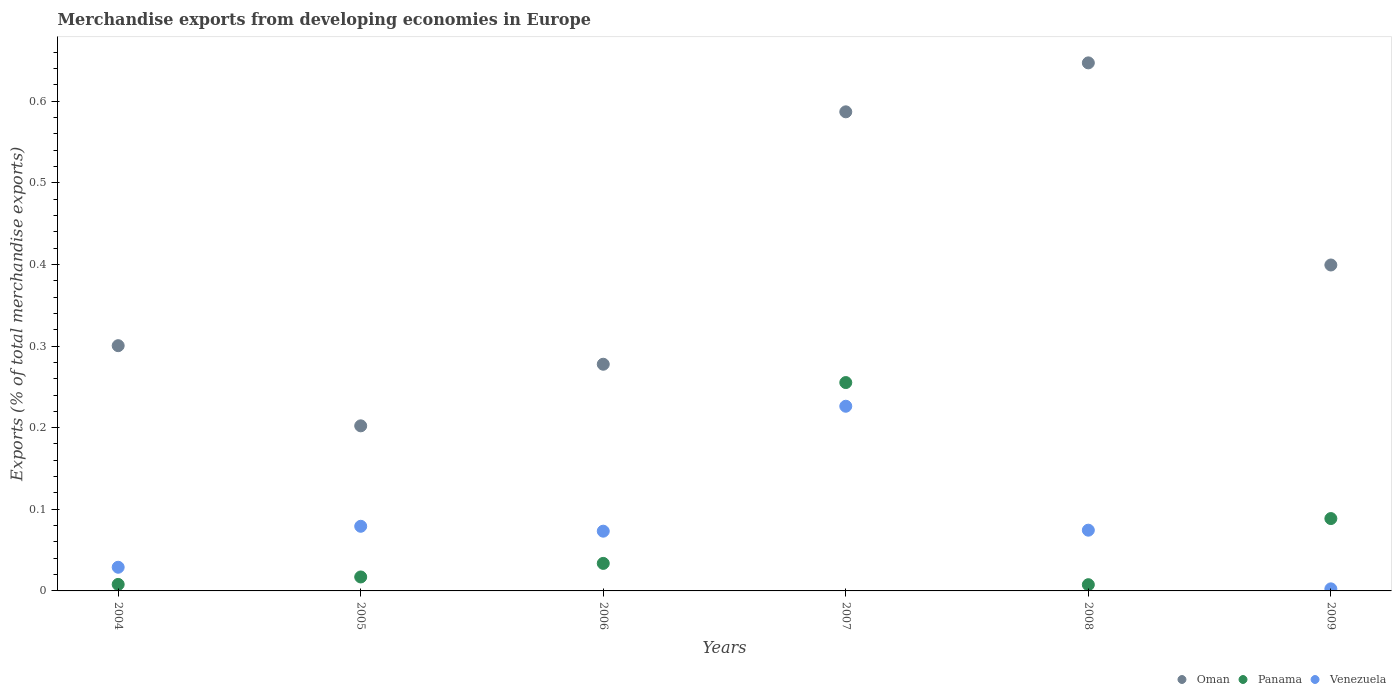How many different coloured dotlines are there?
Your answer should be compact. 3. Is the number of dotlines equal to the number of legend labels?
Your answer should be very brief. Yes. What is the percentage of total merchandise exports in Venezuela in 2004?
Provide a succinct answer. 0.03. Across all years, what is the maximum percentage of total merchandise exports in Oman?
Offer a very short reply. 0.65. Across all years, what is the minimum percentage of total merchandise exports in Oman?
Provide a short and direct response. 0.2. In which year was the percentage of total merchandise exports in Oman maximum?
Your answer should be very brief. 2008. In which year was the percentage of total merchandise exports in Panama minimum?
Make the answer very short. 2008. What is the total percentage of total merchandise exports in Oman in the graph?
Your answer should be compact. 2.41. What is the difference between the percentage of total merchandise exports in Venezuela in 2004 and that in 2007?
Make the answer very short. -0.2. What is the difference between the percentage of total merchandise exports in Panama in 2004 and the percentage of total merchandise exports in Venezuela in 2007?
Offer a very short reply. -0.22. What is the average percentage of total merchandise exports in Panama per year?
Give a very brief answer. 0.07. In the year 2009, what is the difference between the percentage of total merchandise exports in Venezuela and percentage of total merchandise exports in Oman?
Offer a terse response. -0.4. What is the ratio of the percentage of total merchandise exports in Panama in 2004 to that in 2006?
Make the answer very short. 0.24. Is the percentage of total merchandise exports in Venezuela in 2004 less than that in 2007?
Provide a succinct answer. Yes. Is the difference between the percentage of total merchandise exports in Venezuela in 2008 and 2009 greater than the difference between the percentage of total merchandise exports in Oman in 2008 and 2009?
Keep it short and to the point. No. What is the difference between the highest and the second highest percentage of total merchandise exports in Venezuela?
Give a very brief answer. 0.15. What is the difference between the highest and the lowest percentage of total merchandise exports in Oman?
Provide a short and direct response. 0.44. In how many years, is the percentage of total merchandise exports in Panama greater than the average percentage of total merchandise exports in Panama taken over all years?
Make the answer very short. 2. Is the sum of the percentage of total merchandise exports in Oman in 2004 and 2006 greater than the maximum percentage of total merchandise exports in Venezuela across all years?
Offer a very short reply. Yes. Is it the case that in every year, the sum of the percentage of total merchandise exports in Venezuela and percentage of total merchandise exports in Oman  is greater than the percentage of total merchandise exports in Panama?
Provide a succinct answer. Yes. Does the percentage of total merchandise exports in Panama monotonically increase over the years?
Your answer should be very brief. No. What is the difference between two consecutive major ticks on the Y-axis?
Your answer should be compact. 0.1. Does the graph contain grids?
Provide a short and direct response. No. Where does the legend appear in the graph?
Offer a terse response. Bottom right. How are the legend labels stacked?
Give a very brief answer. Horizontal. What is the title of the graph?
Give a very brief answer. Merchandise exports from developing economies in Europe. What is the label or title of the X-axis?
Give a very brief answer. Years. What is the label or title of the Y-axis?
Your answer should be compact. Exports (% of total merchandise exports). What is the Exports (% of total merchandise exports) in Oman in 2004?
Your answer should be very brief. 0.3. What is the Exports (% of total merchandise exports) in Panama in 2004?
Give a very brief answer. 0.01. What is the Exports (% of total merchandise exports) of Venezuela in 2004?
Provide a succinct answer. 0.03. What is the Exports (% of total merchandise exports) in Oman in 2005?
Make the answer very short. 0.2. What is the Exports (% of total merchandise exports) in Panama in 2005?
Provide a succinct answer. 0.02. What is the Exports (% of total merchandise exports) in Venezuela in 2005?
Your answer should be very brief. 0.08. What is the Exports (% of total merchandise exports) of Oman in 2006?
Provide a short and direct response. 0.28. What is the Exports (% of total merchandise exports) in Panama in 2006?
Your answer should be very brief. 0.03. What is the Exports (% of total merchandise exports) in Venezuela in 2006?
Ensure brevity in your answer.  0.07. What is the Exports (% of total merchandise exports) of Oman in 2007?
Your response must be concise. 0.59. What is the Exports (% of total merchandise exports) in Panama in 2007?
Make the answer very short. 0.26. What is the Exports (% of total merchandise exports) in Venezuela in 2007?
Ensure brevity in your answer.  0.23. What is the Exports (% of total merchandise exports) of Oman in 2008?
Offer a terse response. 0.65. What is the Exports (% of total merchandise exports) in Panama in 2008?
Make the answer very short. 0.01. What is the Exports (% of total merchandise exports) in Venezuela in 2008?
Your answer should be very brief. 0.07. What is the Exports (% of total merchandise exports) of Oman in 2009?
Your response must be concise. 0.4. What is the Exports (% of total merchandise exports) in Panama in 2009?
Provide a succinct answer. 0.09. What is the Exports (% of total merchandise exports) of Venezuela in 2009?
Your answer should be very brief. 0. Across all years, what is the maximum Exports (% of total merchandise exports) in Oman?
Provide a short and direct response. 0.65. Across all years, what is the maximum Exports (% of total merchandise exports) in Panama?
Keep it short and to the point. 0.26. Across all years, what is the maximum Exports (% of total merchandise exports) of Venezuela?
Provide a short and direct response. 0.23. Across all years, what is the minimum Exports (% of total merchandise exports) in Oman?
Your answer should be compact. 0.2. Across all years, what is the minimum Exports (% of total merchandise exports) in Panama?
Give a very brief answer. 0.01. Across all years, what is the minimum Exports (% of total merchandise exports) in Venezuela?
Keep it short and to the point. 0. What is the total Exports (% of total merchandise exports) in Oman in the graph?
Ensure brevity in your answer.  2.41. What is the total Exports (% of total merchandise exports) in Panama in the graph?
Provide a short and direct response. 0.41. What is the total Exports (% of total merchandise exports) in Venezuela in the graph?
Your answer should be compact. 0.48. What is the difference between the Exports (% of total merchandise exports) of Oman in 2004 and that in 2005?
Your answer should be very brief. 0.1. What is the difference between the Exports (% of total merchandise exports) of Panama in 2004 and that in 2005?
Ensure brevity in your answer.  -0.01. What is the difference between the Exports (% of total merchandise exports) of Venezuela in 2004 and that in 2005?
Offer a terse response. -0.05. What is the difference between the Exports (% of total merchandise exports) of Oman in 2004 and that in 2006?
Provide a succinct answer. 0.02. What is the difference between the Exports (% of total merchandise exports) in Panama in 2004 and that in 2006?
Offer a very short reply. -0.03. What is the difference between the Exports (% of total merchandise exports) of Venezuela in 2004 and that in 2006?
Offer a very short reply. -0.04. What is the difference between the Exports (% of total merchandise exports) of Oman in 2004 and that in 2007?
Make the answer very short. -0.29. What is the difference between the Exports (% of total merchandise exports) in Panama in 2004 and that in 2007?
Provide a short and direct response. -0.25. What is the difference between the Exports (% of total merchandise exports) in Venezuela in 2004 and that in 2007?
Give a very brief answer. -0.2. What is the difference between the Exports (% of total merchandise exports) in Oman in 2004 and that in 2008?
Ensure brevity in your answer.  -0.35. What is the difference between the Exports (% of total merchandise exports) of Venezuela in 2004 and that in 2008?
Ensure brevity in your answer.  -0.05. What is the difference between the Exports (% of total merchandise exports) of Oman in 2004 and that in 2009?
Ensure brevity in your answer.  -0.1. What is the difference between the Exports (% of total merchandise exports) of Panama in 2004 and that in 2009?
Provide a short and direct response. -0.08. What is the difference between the Exports (% of total merchandise exports) of Venezuela in 2004 and that in 2009?
Your answer should be compact. 0.03. What is the difference between the Exports (% of total merchandise exports) of Oman in 2005 and that in 2006?
Give a very brief answer. -0.08. What is the difference between the Exports (% of total merchandise exports) in Panama in 2005 and that in 2006?
Provide a short and direct response. -0.02. What is the difference between the Exports (% of total merchandise exports) of Venezuela in 2005 and that in 2006?
Give a very brief answer. 0.01. What is the difference between the Exports (% of total merchandise exports) of Oman in 2005 and that in 2007?
Your answer should be compact. -0.38. What is the difference between the Exports (% of total merchandise exports) in Panama in 2005 and that in 2007?
Provide a succinct answer. -0.24. What is the difference between the Exports (% of total merchandise exports) of Venezuela in 2005 and that in 2007?
Offer a very short reply. -0.15. What is the difference between the Exports (% of total merchandise exports) of Oman in 2005 and that in 2008?
Give a very brief answer. -0.44. What is the difference between the Exports (% of total merchandise exports) of Panama in 2005 and that in 2008?
Your response must be concise. 0.01. What is the difference between the Exports (% of total merchandise exports) in Venezuela in 2005 and that in 2008?
Provide a succinct answer. 0. What is the difference between the Exports (% of total merchandise exports) in Oman in 2005 and that in 2009?
Offer a very short reply. -0.2. What is the difference between the Exports (% of total merchandise exports) in Panama in 2005 and that in 2009?
Ensure brevity in your answer.  -0.07. What is the difference between the Exports (% of total merchandise exports) of Venezuela in 2005 and that in 2009?
Provide a short and direct response. 0.08. What is the difference between the Exports (% of total merchandise exports) in Oman in 2006 and that in 2007?
Your answer should be very brief. -0.31. What is the difference between the Exports (% of total merchandise exports) in Panama in 2006 and that in 2007?
Offer a very short reply. -0.22. What is the difference between the Exports (% of total merchandise exports) of Venezuela in 2006 and that in 2007?
Provide a short and direct response. -0.15. What is the difference between the Exports (% of total merchandise exports) of Oman in 2006 and that in 2008?
Offer a very short reply. -0.37. What is the difference between the Exports (% of total merchandise exports) of Panama in 2006 and that in 2008?
Offer a terse response. 0.03. What is the difference between the Exports (% of total merchandise exports) in Venezuela in 2006 and that in 2008?
Your answer should be very brief. -0. What is the difference between the Exports (% of total merchandise exports) in Oman in 2006 and that in 2009?
Give a very brief answer. -0.12. What is the difference between the Exports (% of total merchandise exports) in Panama in 2006 and that in 2009?
Make the answer very short. -0.05. What is the difference between the Exports (% of total merchandise exports) of Venezuela in 2006 and that in 2009?
Ensure brevity in your answer.  0.07. What is the difference between the Exports (% of total merchandise exports) in Oman in 2007 and that in 2008?
Your answer should be compact. -0.06. What is the difference between the Exports (% of total merchandise exports) in Panama in 2007 and that in 2008?
Your answer should be compact. 0.25. What is the difference between the Exports (% of total merchandise exports) of Venezuela in 2007 and that in 2008?
Make the answer very short. 0.15. What is the difference between the Exports (% of total merchandise exports) in Oman in 2007 and that in 2009?
Offer a very short reply. 0.19. What is the difference between the Exports (% of total merchandise exports) in Panama in 2007 and that in 2009?
Your answer should be very brief. 0.17. What is the difference between the Exports (% of total merchandise exports) of Venezuela in 2007 and that in 2009?
Your answer should be very brief. 0.22. What is the difference between the Exports (% of total merchandise exports) of Oman in 2008 and that in 2009?
Keep it short and to the point. 0.25. What is the difference between the Exports (% of total merchandise exports) of Panama in 2008 and that in 2009?
Offer a very short reply. -0.08. What is the difference between the Exports (% of total merchandise exports) in Venezuela in 2008 and that in 2009?
Your answer should be very brief. 0.07. What is the difference between the Exports (% of total merchandise exports) of Oman in 2004 and the Exports (% of total merchandise exports) of Panama in 2005?
Provide a short and direct response. 0.28. What is the difference between the Exports (% of total merchandise exports) in Oman in 2004 and the Exports (% of total merchandise exports) in Venezuela in 2005?
Make the answer very short. 0.22. What is the difference between the Exports (% of total merchandise exports) in Panama in 2004 and the Exports (% of total merchandise exports) in Venezuela in 2005?
Make the answer very short. -0.07. What is the difference between the Exports (% of total merchandise exports) of Oman in 2004 and the Exports (% of total merchandise exports) of Panama in 2006?
Your response must be concise. 0.27. What is the difference between the Exports (% of total merchandise exports) of Oman in 2004 and the Exports (% of total merchandise exports) of Venezuela in 2006?
Provide a short and direct response. 0.23. What is the difference between the Exports (% of total merchandise exports) in Panama in 2004 and the Exports (% of total merchandise exports) in Venezuela in 2006?
Ensure brevity in your answer.  -0.07. What is the difference between the Exports (% of total merchandise exports) of Oman in 2004 and the Exports (% of total merchandise exports) of Panama in 2007?
Your answer should be compact. 0.05. What is the difference between the Exports (% of total merchandise exports) of Oman in 2004 and the Exports (% of total merchandise exports) of Venezuela in 2007?
Provide a succinct answer. 0.07. What is the difference between the Exports (% of total merchandise exports) in Panama in 2004 and the Exports (% of total merchandise exports) in Venezuela in 2007?
Keep it short and to the point. -0.22. What is the difference between the Exports (% of total merchandise exports) in Oman in 2004 and the Exports (% of total merchandise exports) in Panama in 2008?
Offer a terse response. 0.29. What is the difference between the Exports (% of total merchandise exports) of Oman in 2004 and the Exports (% of total merchandise exports) of Venezuela in 2008?
Give a very brief answer. 0.23. What is the difference between the Exports (% of total merchandise exports) of Panama in 2004 and the Exports (% of total merchandise exports) of Venezuela in 2008?
Offer a very short reply. -0.07. What is the difference between the Exports (% of total merchandise exports) of Oman in 2004 and the Exports (% of total merchandise exports) of Panama in 2009?
Your answer should be compact. 0.21. What is the difference between the Exports (% of total merchandise exports) in Oman in 2004 and the Exports (% of total merchandise exports) in Venezuela in 2009?
Keep it short and to the point. 0.3. What is the difference between the Exports (% of total merchandise exports) in Panama in 2004 and the Exports (% of total merchandise exports) in Venezuela in 2009?
Offer a terse response. 0.01. What is the difference between the Exports (% of total merchandise exports) in Oman in 2005 and the Exports (% of total merchandise exports) in Panama in 2006?
Your response must be concise. 0.17. What is the difference between the Exports (% of total merchandise exports) in Oman in 2005 and the Exports (% of total merchandise exports) in Venezuela in 2006?
Offer a terse response. 0.13. What is the difference between the Exports (% of total merchandise exports) of Panama in 2005 and the Exports (% of total merchandise exports) of Venezuela in 2006?
Your response must be concise. -0.06. What is the difference between the Exports (% of total merchandise exports) of Oman in 2005 and the Exports (% of total merchandise exports) of Panama in 2007?
Keep it short and to the point. -0.05. What is the difference between the Exports (% of total merchandise exports) in Oman in 2005 and the Exports (% of total merchandise exports) in Venezuela in 2007?
Your response must be concise. -0.02. What is the difference between the Exports (% of total merchandise exports) of Panama in 2005 and the Exports (% of total merchandise exports) of Venezuela in 2007?
Ensure brevity in your answer.  -0.21. What is the difference between the Exports (% of total merchandise exports) in Oman in 2005 and the Exports (% of total merchandise exports) in Panama in 2008?
Your answer should be compact. 0.19. What is the difference between the Exports (% of total merchandise exports) in Oman in 2005 and the Exports (% of total merchandise exports) in Venezuela in 2008?
Offer a very short reply. 0.13. What is the difference between the Exports (% of total merchandise exports) in Panama in 2005 and the Exports (% of total merchandise exports) in Venezuela in 2008?
Keep it short and to the point. -0.06. What is the difference between the Exports (% of total merchandise exports) of Oman in 2005 and the Exports (% of total merchandise exports) of Panama in 2009?
Offer a terse response. 0.11. What is the difference between the Exports (% of total merchandise exports) of Oman in 2005 and the Exports (% of total merchandise exports) of Venezuela in 2009?
Provide a short and direct response. 0.2. What is the difference between the Exports (% of total merchandise exports) of Panama in 2005 and the Exports (% of total merchandise exports) of Venezuela in 2009?
Give a very brief answer. 0.01. What is the difference between the Exports (% of total merchandise exports) in Oman in 2006 and the Exports (% of total merchandise exports) in Panama in 2007?
Provide a short and direct response. 0.02. What is the difference between the Exports (% of total merchandise exports) in Oman in 2006 and the Exports (% of total merchandise exports) in Venezuela in 2007?
Give a very brief answer. 0.05. What is the difference between the Exports (% of total merchandise exports) of Panama in 2006 and the Exports (% of total merchandise exports) of Venezuela in 2007?
Offer a terse response. -0.19. What is the difference between the Exports (% of total merchandise exports) in Oman in 2006 and the Exports (% of total merchandise exports) in Panama in 2008?
Offer a very short reply. 0.27. What is the difference between the Exports (% of total merchandise exports) of Oman in 2006 and the Exports (% of total merchandise exports) of Venezuela in 2008?
Your answer should be very brief. 0.2. What is the difference between the Exports (% of total merchandise exports) of Panama in 2006 and the Exports (% of total merchandise exports) of Venezuela in 2008?
Provide a short and direct response. -0.04. What is the difference between the Exports (% of total merchandise exports) in Oman in 2006 and the Exports (% of total merchandise exports) in Panama in 2009?
Provide a short and direct response. 0.19. What is the difference between the Exports (% of total merchandise exports) in Oman in 2006 and the Exports (% of total merchandise exports) in Venezuela in 2009?
Offer a very short reply. 0.28. What is the difference between the Exports (% of total merchandise exports) of Panama in 2006 and the Exports (% of total merchandise exports) of Venezuela in 2009?
Ensure brevity in your answer.  0.03. What is the difference between the Exports (% of total merchandise exports) of Oman in 2007 and the Exports (% of total merchandise exports) of Panama in 2008?
Your answer should be very brief. 0.58. What is the difference between the Exports (% of total merchandise exports) of Oman in 2007 and the Exports (% of total merchandise exports) of Venezuela in 2008?
Keep it short and to the point. 0.51. What is the difference between the Exports (% of total merchandise exports) in Panama in 2007 and the Exports (% of total merchandise exports) in Venezuela in 2008?
Provide a short and direct response. 0.18. What is the difference between the Exports (% of total merchandise exports) in Oman in 2007 and the Exports (% of total merchandise exports) in Panama in 2009?
Give a very brief answer. 0.5. What is the difference between the Exports (% of total merchandise exports) of Oman in 2007 and the Exports (% of total merchandise exports) of Venezuela in 2009?
Provide a short and direct response. 0.58. What is the difference between the Exports (% of total merchandise exports) of Panama in 2007 and the Exports (% of total merchandise exports) of Venezuela in 2009?
Provide a short and direct response. 0.25. What is the difference between the Exports (% of total merchandise exports) of Oman in 2008 and the Exports (% of total merchandise exports) of Panama in 2009?
Provide a succinct answer. 0.56. What is the difference between the Exports (% of total merchandise exports) of Oman in 2008 and the Exports (% of total merchandise exports) of Venezuela in 2009?
Offer a very short reply. 0.64. What is the difference between the Exports (% of total merchandise exports) of Panama in 2008 and the Exports (% of total merchandise exports) of Venezuela in 2009?
Provide a short and direct response. 0.01. What is the average Exports (% of total merchandise exports) in Oman per year?
Your response must be concise. 0.4. What is the average Exports (% of total merchandise exports) in Panama per year?
Make the answer very short. 0.07. What is the average Exports (% of total merchandise exports) of Venezuela per year?
Ensure brevity in your answer.  0.08. In the year 2004, what is the difference between the Exports (% of total merchandise exports) of Oman and Exports (% of total merchandise exports) of Panama?
Your answer should be compact. 0.29. In the year 2004, what is the difference between the Exports (% of total merchandise exports) of Oman and Exports (% of total merchandise exports) of Venezuela?
Ensure brevity in your answer.  0.27. In the year 2004, what is the difference between the Exports (% of total merchandise exports) of Panama and Exports (% of total merchandise exports) of Venezuela?
Provide a short and direct response. -0.02. In the year 2005, what is the difference between the Exports (% of total merchandise exports) of Oman and Exports (% of total merchandise exports) of Panama?
Your response must be concise. 0.19. In the year 2005, what is the difference between the Exports (% of total merchandise exports) of Oman and Exports (% of total merchandise exports) of Venezuela?
Your response must be concise. 0.12. In the year 2005, what is the difference between the Exports (% of total merchandise exports) of Panama and Exports (% of total merchandise exports) of Venezuela?
Give a very brief answer. -0.06. In the year 2006, what is the difference between the Exports (% of total merchandise exports) in Oman and Exports (% of total merchandise exports) in Panama?
Offer a very short reply. 0.24. In the year 2006, what is the difference between the Exports (% of total merchandise exports) in Oman and Exports (% of total merchandise exports) in Venezuela?
Provide a short and direct response. 0.2. In the year 2006, what is the difference between the Exports (% of total merchandise exports) in Panama and Exports (% of total merchandise exports) in Venezuela?
Offer a very short reply. -0.04. In the year 2007, what is the difference between the Exports (% of total merchandise exports) of Oman and Exports (% of total merchandise exports) of Panama?
Offer a terse response. 0.33. In the year 2007, what is the difference between the Exports (% of total merchandise exports) of Oman and Exports (% of total merchandise exports) of Venezuela?
Your response must be concise. 0.36. In the year 2007, what is the difference between the Exports (% of total merchandise exports) in Panama and Exports (% of total merchandise exports) in Venezuela?
Make the answer very short. 0.03. In the year 2008, what is the difference between the Exports (% of total merchandise exports) in Oman and Exports (% of total merchandise exports) in Panama?
Your answer should be compact. 0.64. In the year 2008, what is the difference between the Exports (% of total merchandise exports) of Oman and Exports (% of total merchandise exports) of Venezuela?
Keep it short and to the point. 0.57. In the year 2008, what is the difference between the Exports (% of total merchandise exports) of Panama and Exports (% of total merchandise exports) of Venezuela?
Your response must be concise. -0.07. In the year 2009, what is the difference between the Exports (% of total merchandise exports) of Oman and Exports (% of total merchandise exports) of Panama?
Ensure brevity in your answer.  0.31. In the year 2009, what is the difference between the Exports (% of total merchandise exports) of Oman and Exports (% of total merchandise exports) of Venezuela?
Your response must be concise. 0.4. In the year 2009, what is the difference between the Exports (% of total merchandise exports) of Panama and Exports (% of total merchandise exports) of Venezuela?
Your response must be concise. 0.09. What is the ratio of the Exports (% of total merchandise exports) in Oman in 2004 to that in 2005?
Offer a very short reply. 1.49. What is the ratio of the Exports (% of total merchandise exports) in Panama in 2004 to that in 2005?
Offer a very short reply. 0.47. What is the ratio of the Exports (% of total merchandise exports) of Venezuela in 2004 to that in 2005?
Provide a short and direct response. 0.37. What is the ratio of the Exports (% of total merchandise exports) of Oman in 2004 to that in 2006?
Your answer should be compact. 1.08. What is the ratio of the Exports (% of total merchandise exports) of Panama in 2004 to that in 2006?
Give a very brief answer. 0.24. What is the ratio of the Exports (% of total merchandise exports) of Venezuela in 2004 to that in 2006?
Offer a very short reply. 0.4. What is the ratio of the Exports (% of total merchandise exports) of Oman in 2004 to that in 2007?
Provide a short and direct response. 0.51. What is the ratio of the Exports (% of total merchandise exports) in Panama in 2004 to that in 2007?
Offer a terse response. 0.03. What is the ratio of the Exports (% of total merchandise exports) of Venezuela in 2004 to that in 2007?
Ensure brevity in your answer.  0.13. What is the ratio of the Exports (% of total merchandise exports) in Oman in 2004 to that in 2008?
Your answer should be very brief. 0.46. What is the ratio of the Exports (% of total merchandise exports) in Panama in 2004 to that in 2008?
Your answer should be very brief. 1.04. What is the ratio of the Exports (% of total merchandise exports) of Venezuela in 2004 to that in 2008?
Your answer should be very brief. 0.39. What is the ratio of the Exports (% of total merchandise exports) of Oman in 2004 to that in 2009?
Offer a terse response. 0.75. What is the ratio of the Exports (% of total merchandise exports) of Panama in 2004 to that in 2009?
Provide a succinct answer. 0.09. What is the ratio of the Exports (% of total merchandise exports) in Venezuela in 2004 to that in 2009?
Keep it short and to the point. 11.46. What is the ratio of the Exports (% of total merchandise exports) of Oman in 2005 to that in 2006?
Ensure brevity in your answer.  0.73. What is the ratio of the Exports (% of total merchandise exports) in Panama in 2005 to that in 2006?
Your answer should be very brief. 0.51. What is the ratio of the Exports (% of total merchandise exports) of Venezuela in 2005 to that in 2006?
Ensure brevity in your answer.  1.08. What is the ratio of the Exports (% of total merchandise exports) in Oman in 2005 to that in 2007?
Your response must be concise. 0.34. What is the ratio of the Exports (% of total merchandise exports) of Panama in 2005 to that in 2007?
Offer a terse response. 0.07. What is the ratio of the Exports (% of total merchandise exports) in Oman in 2005 to that in 2008?
Provide a short and direct response. 0.31. What is the ratio of the Exports (% of total merchandise exports) of Panama in 2005 to that in 2008?
Your response must be concise. 2.24. What is the ratio of the Exports (% of total merchandise exports) of Venezuela in 2005 to that in 2008?
Offer a terse response. 1.06. What is the ratio of the Exports (% of total merchandise exports) in Oman in 2005 to that in 2009?
Give a very brief answer. 0.51. What is the ratio of the Exports (% of total merchandise exports) of Panama in 2005 to that in 2009?
Provide a succinct answer. 0.19. What is the ratio of the Exports (% of total merchandise exports) in Venezuela in 2005 to that in 2009?
Give a very brief answer. 31.3. What is the ratio of the Exports (% of total merchandise exports) in Oman in 2006 to that in 2007?
Provide a short and direct response. 0.47. What is the ratio of the Exports (% of total merchandise exports) in Panama in 2006 to that in 2007?
Provide a short and direct response. 0.13. What is the ratio of the Exports (% of total merchandise exports) of Venezuela in 2006 to that in 2007?
Your answer should be very brief. 0.32. What is the ratio of the Exports (% of total merchandise exports) in Oman in 2006 to that in 2008?
Your answer should be very brief. 0.43. What is the ratio of the Exports (% of total merchandise exports) of Panama in 2006 to that in 2008?
Make the answer very short. 4.42. What is the ratio of the Exports (% of total merchandise exports) in Venezuela in 2006 to that in 2008?
Offer a terse response. 0.98. What is the ratio of the Exports (% of total merchandise exports) in Oman in 2006 to that in 2009?
Offer a very short reply. 0.7. What is the ratio of the Exports (% of total merchandise exports) of Panama in 2006 to that in 2009?
Ensure brevity in your answer.  0.38. What is the ratio of the Exports (% of total merchandise exports) in Venezuela in 2006 to that in 2009?
Ensure brevity in your answer.  28.93. What is the ratio of the Exports (% of total merchandise exports) in Oman in 2007 to that in 2008?
Your answer should be compact. 0.91. What is the ratio of the Exports (% of total merchandise exports) of Panama in 2007 to that in 2008?
Offer a very short reply. 33.42. What is the ratio of the Exports (% of total merchandise exports) in Venezuela in 2007 to that in 2008?
Make the answer very short. 3.04. What is the ratio of the Exports (% of total merchandise exports) of Oman in 2007 to that in 2009?
Give a very brief answer. 1.47. What is the ratio of the Exports (% of total merchandise exports) in Panama in 2007 to that in 2009?
Ensure brevity in your answer.  2.88. What is the ratio of the Exports (% of total merchandise exports) in Venezuela in 2007 to that in 2009?
Your response must be concise. 89.43. What is the ratio of the Exports (% of total merchandise exports) in Oman in 2008 to that in 2009?
Give a very brief answer. 1.62. What is the ratio of the Exports (% of total merchandise exports) in Panama in 2008 to that in 2009?
Keep it short and to the point. 0.09. What is the ratio of the Exports (% of total merchandise exports) of Venezuela in 2008 to that in 2009?
Offer a terse response. 29.41. What is the difference between the highest and the second highest Exports (% of total merchandise exports) in Oman?
Provide a short and direct response. 0.06. What is the difference between the highest and the second highest Exports (% of total merchandise exports) of Panama?
Keep it short and to the point. 0.17. What is the difference between the highest and the second highest Exports (% of total merchandise exports) in Venezuela?
Your answer should be very brief. 0.15. What is the difference between the highest and the lowest Exports (% of total merchandise exports) of Oman?
Offer a terse response. 0.44. What is the difference between the highest and the lowest Exports (% of total merchandise exports) in Panama?
Offer a terse response. 0.25. What is the difference between the highest and the lowest Exports (% of total merchandise exports) in Venezuela?
Give a very brief answer. 0.22. 